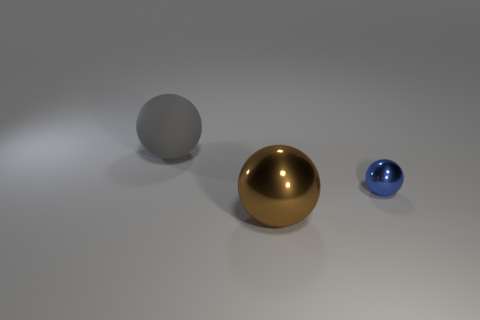Subtract all tiny balls. How many balls are left? 2 Add 3 small gray cylinders. How many objects exist? 6 Subtract all brown spheres. How many spheres are left? 2 Add 3 big yellow shiny spheres. How many big yellow shiny spheres exist? 3 Subtract 0 brown cylinders. How many objects are left? 3 Subtract all brown balls. Subtract all brown cylinders. How many balls are left? 2 Subtract all large gray rubber objects. Subtract all tiny objects. How many objects are left? 1 Add 3 small blue balls. How many small blue balls are left? 4 